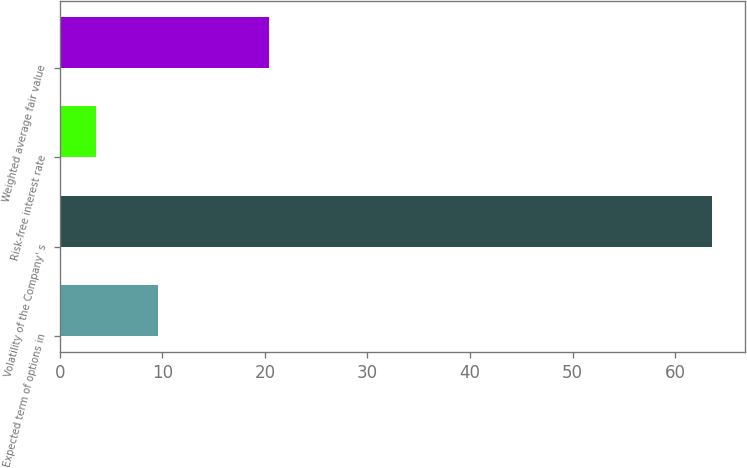Convert chart to OTSL. <chart><loc_0><loc_0><loc_500><loc_500><bar_chart><fcel>Expected term of options in<fcel>Volatility of the Company' s<fcel>Risk-free interest rate<fcel>Weighted average fair value<nl><fcel>9.58<fcel>63.6<fcel>3.58<fcel>20.4<nl></chart> 